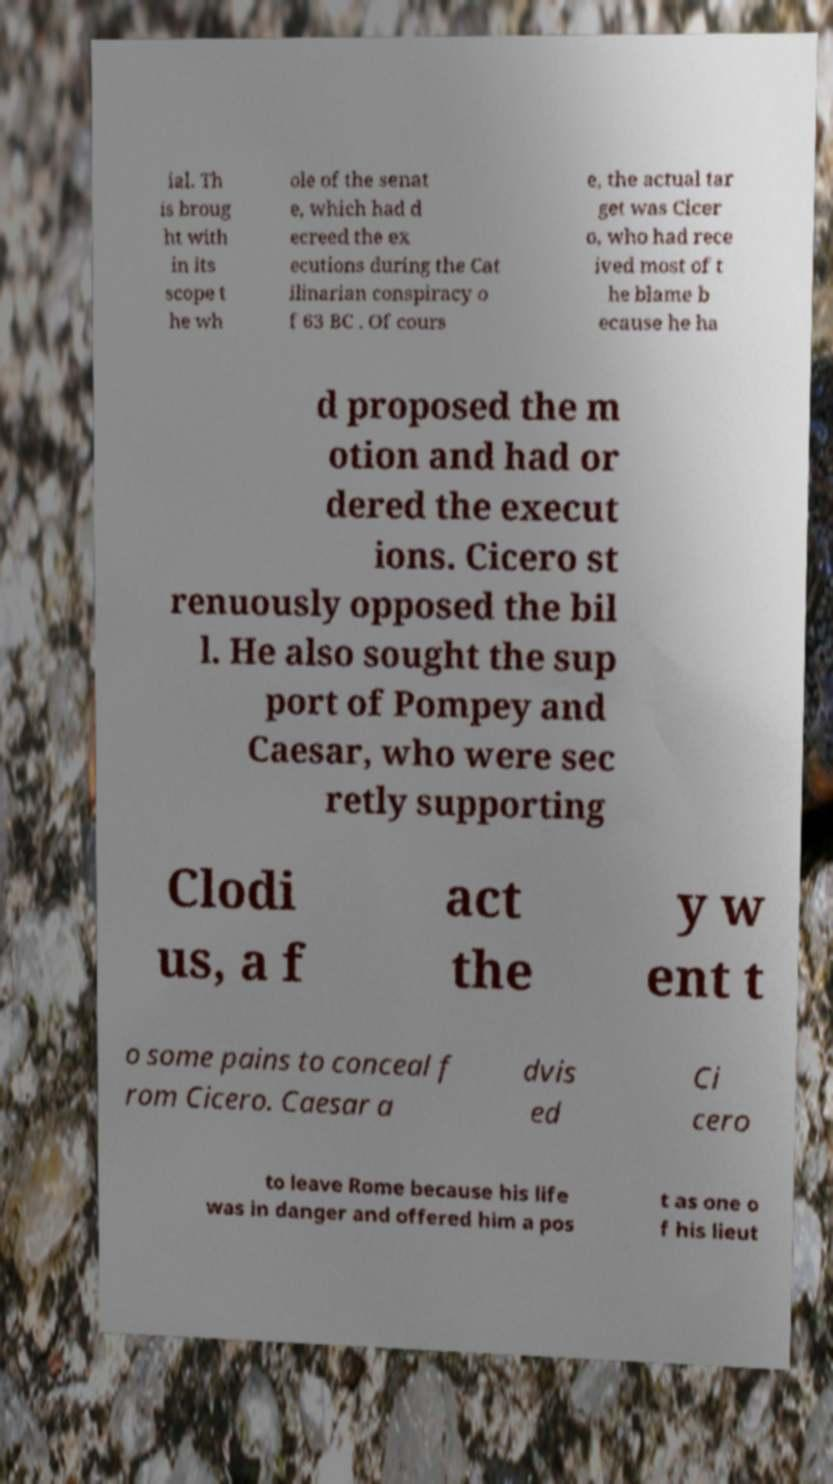There's text embedded in this image that I need extracted. Can you transcribe it verbatim? ial. Th is broug ht with in its scope t he wh ole of the senat e, which had d ecreed the ex ecutions during the Cat ilinarian conspiracy o f 63 BC . Of cours e, the actual tar get was Cicer o, who had rece ived most of t he blame b ecause he ha d proposed the m otion and had or dered the execut ions. Cicero st renuously opposed the bil l. He also sought the sup port of Pompey and Caesar, who were sec retly supporting Clodi us, a f act the y w ent t o some pains to conceal f rom Cicero. Caesar a dvis ed Ci cero to leave Rome because his life was in danger and offered him a pos t as one o f his lieut 